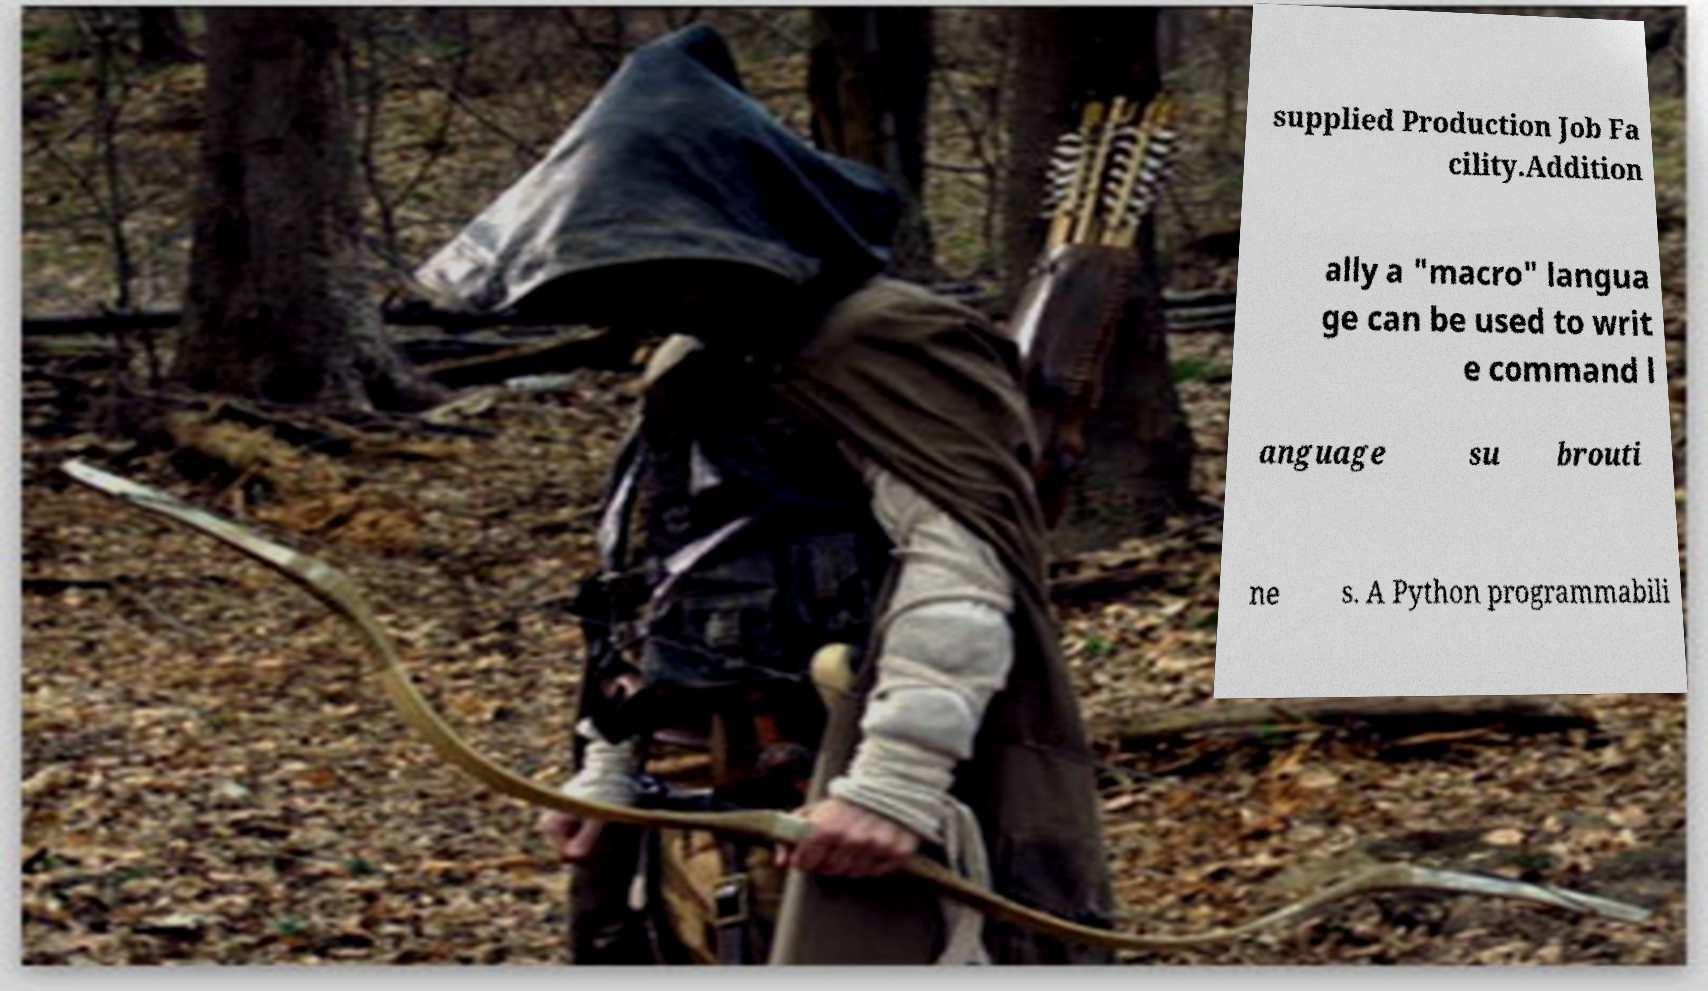I need the written content from this picture converted into text. Can you do that? supplied Production Job Fa cility.Addition ally a "macro" langua ge can be used to writ e command l anguage su brouti ne s. A Python programmabili 